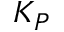Convert formula to latex. <formula><loc_0><loc_0><loc_500><loc_500>K _ { P }</formula> 